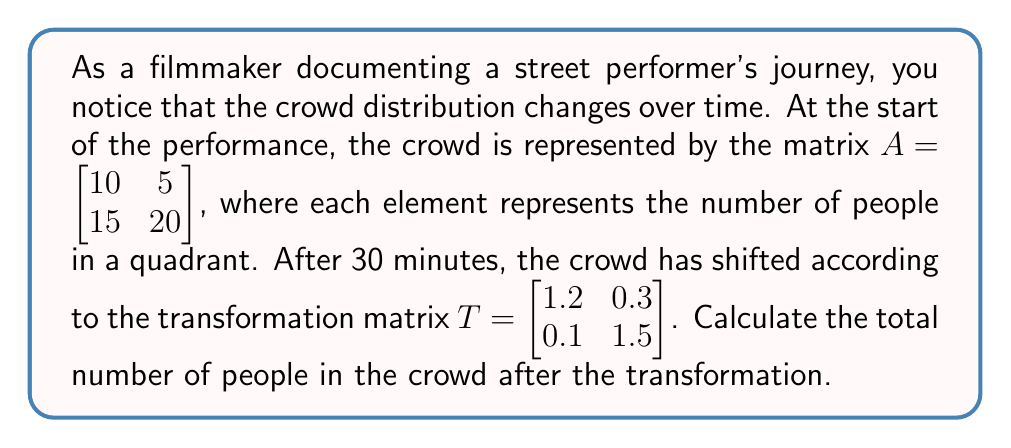Can you solve this math problem? To solve this problem, we need to follow these steps:

1) First, we need to apply the transformation matrix $T$ to the initial crowd distribution matrix $A$. This is done by matrix multiplication:

   $B = T \cdot A$

2) Let's perform the matrix multiplication:

   $B = \begin{bmatrix} 1.2 & 0.3 \\ 0.1 & 1.5 \end{bmatrix} \cdot \begin{bmatrix} 10 & 5 \\ 15 & 20 \end{bmatrix}$

3) Calculating each element of the resulting matrix:

   $b_{11} = 1.2(10) + 0.3(15) = 12 + 4.5 = 16.5$
   $b_{12} = 1.2(5) + 0.3(20) = 6 + 6 = 12$
   $b_{21} = 0.1(10) + 1.5(15) = 1 + 22.5 = 23.5$
   $b_{22} = 0.1(5) + 1.5(20) = 0.5 + 30 = 30.5$

4) So, the transformed crowd distribution matrix is:

   $B = \begin{bmatrix} 16.5 & 12 \\ 23.5 & 30.5 \end{bmatrix}$

5) To find the total number of people, we need to sum all elements of this matrix:

   Total = 16.5 + 12 + 23.5 + 30.5 = 82.5

6) Since we're dealing with people, we need to round this to the nearest whole number:

   Total ≈ 83 people
Answer: 83 people 